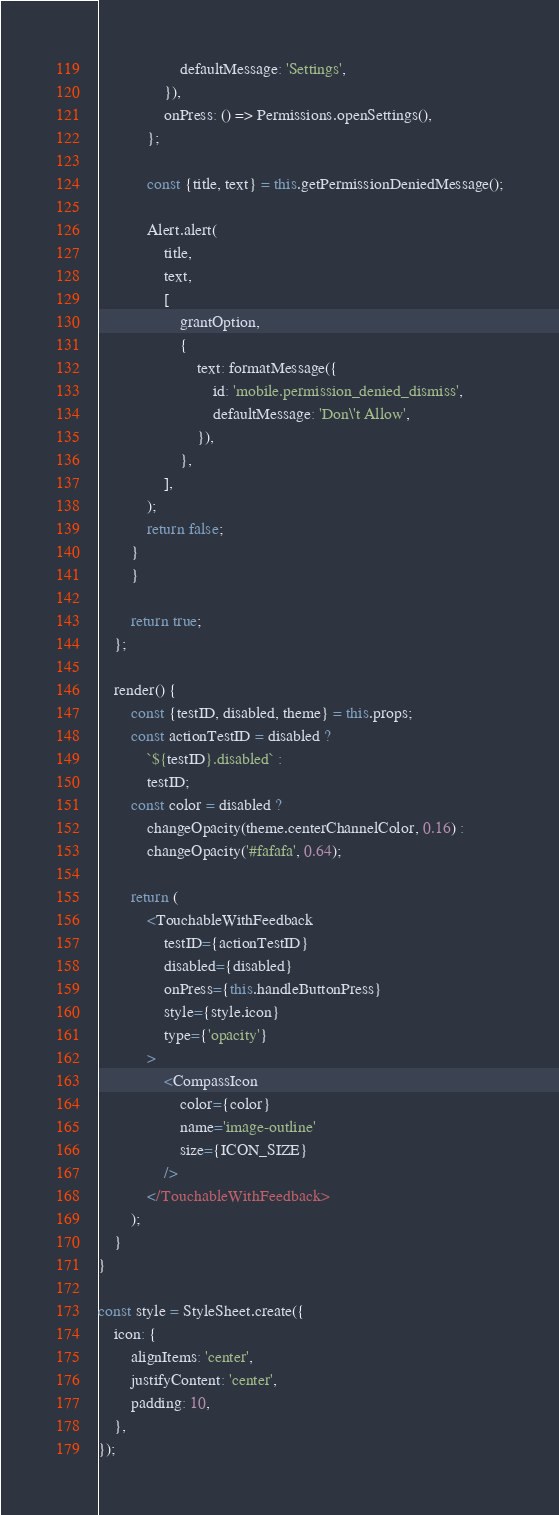<code> <loc_0><loc_0><loc_500><loc_500><_JavaScript_>                    defaultMessage: 'Settings',
                }),
                onPress: () => Permissions.openSettings(),
            };

            const {title, text} = this.getPermissionDeniedMessage();

            Alert.alert(
                title,
                text,
                [
                    grantOption,
                    {
                        text: formatMessage({
                            id: 'mobile.permission_denied_dismiss',
                            defaultMessage: 'Don\'t Allow',
                        }),
                    },
                ],
            );
            return false;
        }
        }

        return true;
    };

    render() {
        const {testID, disabled, theme} = this.props;
        const actionTestID = disabled ?
            `${testID}.disabled` :
            testID;
        const color = disabled ?
            changeOpacity(theme.centerChannelColor, 0.16) :
            changeOpacity('#fafafa', 0.64);

        return (
            <TouchableWithFeedback
                testID={actionTestID}
                disabled={disabled}
                onPress={this.handleButtonPress}
                style={style.icon}
                type={'opacity'}
            >
                <CompassIcon
                    color={color}
                    name='image-outline'
                    size={ICON_SIZE}
                />
            </TouchableWithFeedback>
        );
    }
}

const style = StyleSheet.create({
    icon: {
        alignItems: 'center',
        justifyContent: 'center',
        padding: 10,
    },
});
</code> 